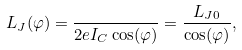<formula> <loc_0><loc_0><loc_500><loc_500>L _ { J } ( \varphi ) = \frac { } { 2 e I _ { C } \cos ( \varphi ) } = \frac { L _ { J 0 } } { \cos ( \varphi ) } ,</formula> 